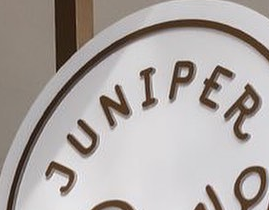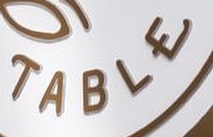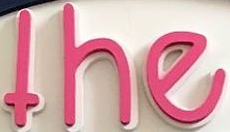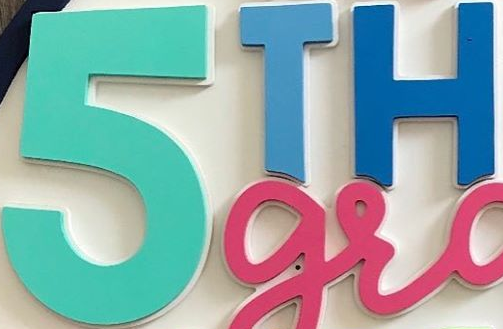Transcribe the words shown in these images in order, separated by a semicolon. JUNIPER; TABLE; the; 5TH 